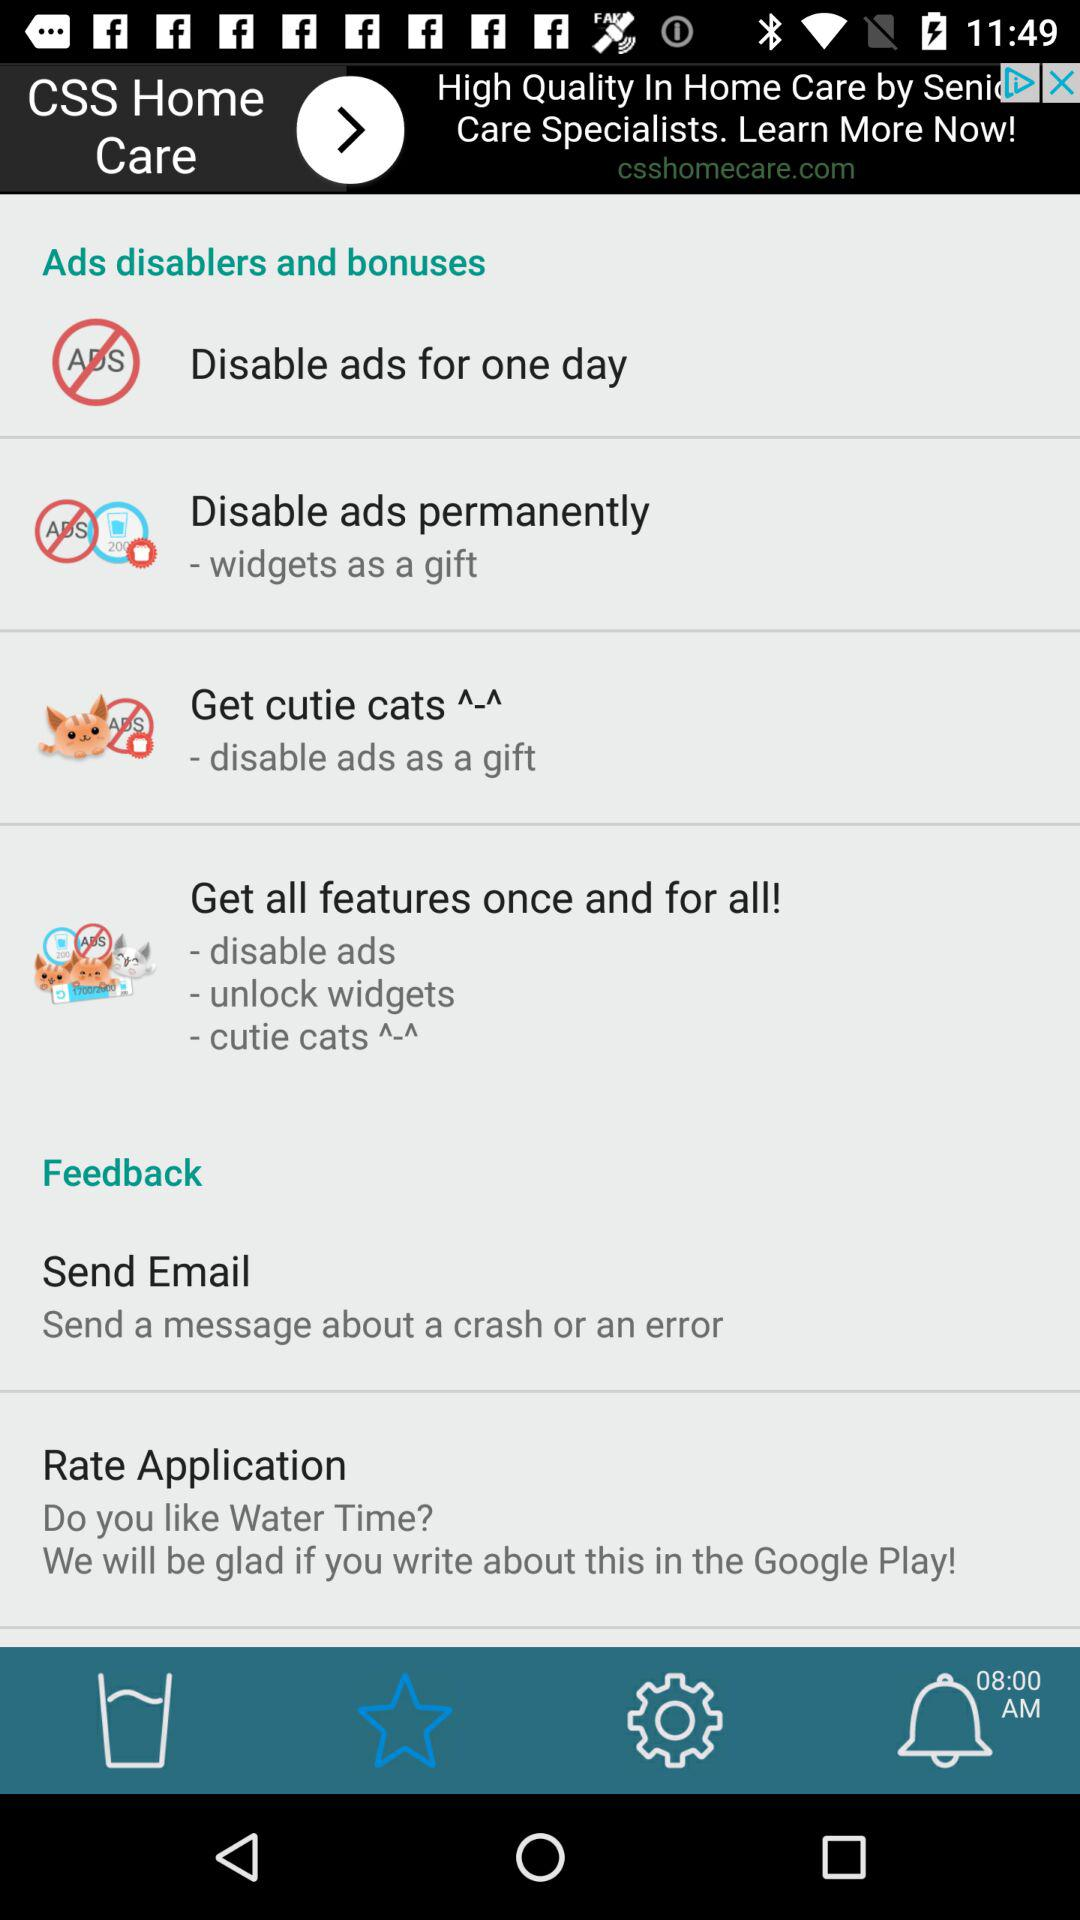How many of the disablers and bonuses have a gift?
Answer the question using a single word or phrase. 2 